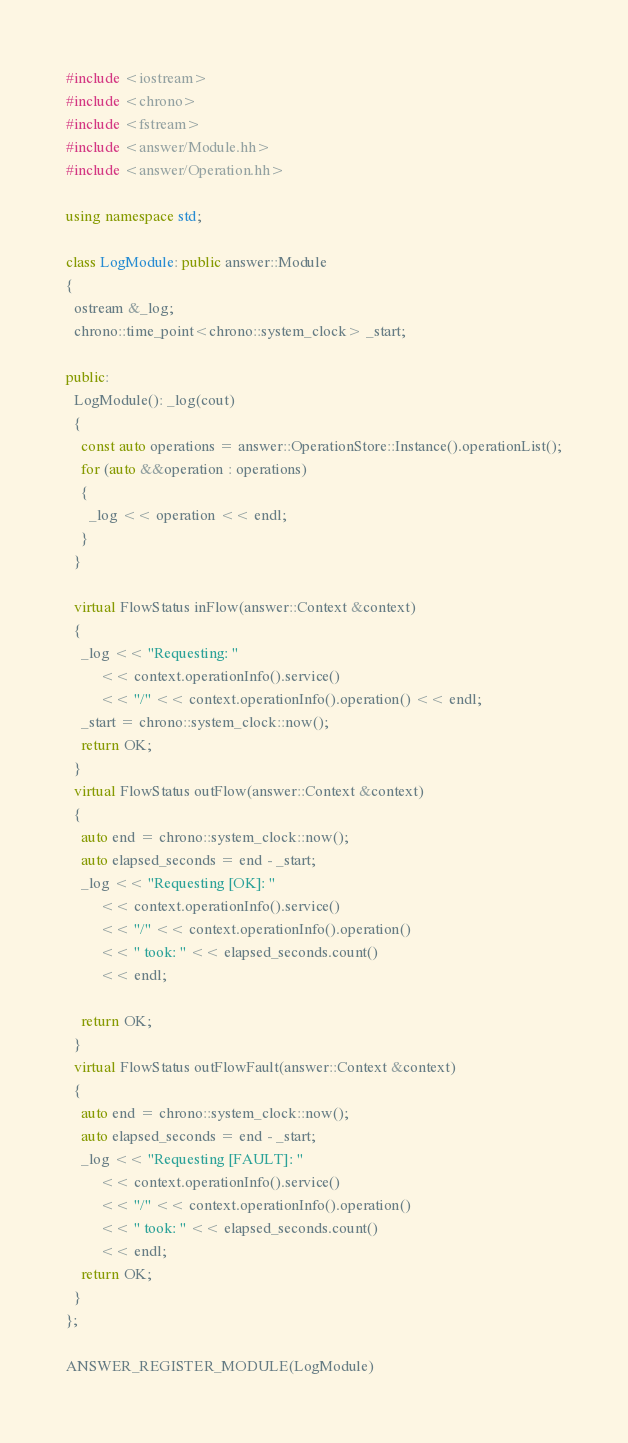<code> <loc_0><loc_0><loc_500><loc_500><_C++_>#include <iostream>
#include <chrono>
#include <fstream>
#include <answer/Module.hh>
#include <answer/Operation.hh>

using namespace std;

class LogModule: public answer::Module
{
  ostream &_log;
  chrono::time_point<chrono::system_clock> _start;

public:
  LogModule(): _log(cout)
  {
    const auto operations = answer::OperationStore::Instance().operationList();
    for (auto &&operation : operations)
    {
      _log << operation << endl;
    }
  }

  virtual FlowStatus inFlow(answer::Context &context)
  {
    _log << "Requesting: "
         << context.operationInfo().service()
         << "/" << context.operationInfo().operation() << endl;
    _start = chrono::system_clock::now();
    return OK;
  }
  virtual FlowStatus outFlow(answer::Context &context)
  {
    auto end = chrono::system_clock::now();
    auto elapsed_seconds = end - _start;
    _log << "Requesting [OK]: "
         << context.operationInfo().service()
         << "/" << context.operationInfo().operation()
         << " took: " << elapsed_seconds.count()
         << endl;

    return OK;
  }
  virtual FlowStatus outFlowFault(answer::Context &context)
  {
    auto end = chrono::system_clock::now();
    auto elapsed_seconds = end - _start;
    _log << "Requesting [FAULT]: "
         << context.operationInfo().service()
         << "/" << context.operationInfo().operation()
         << " took: " << elapsed_seconds.count()
         << endl;
    return OK;
  }
};

ANSWER_REGISTER_MODULE(LogModule)
</code> 